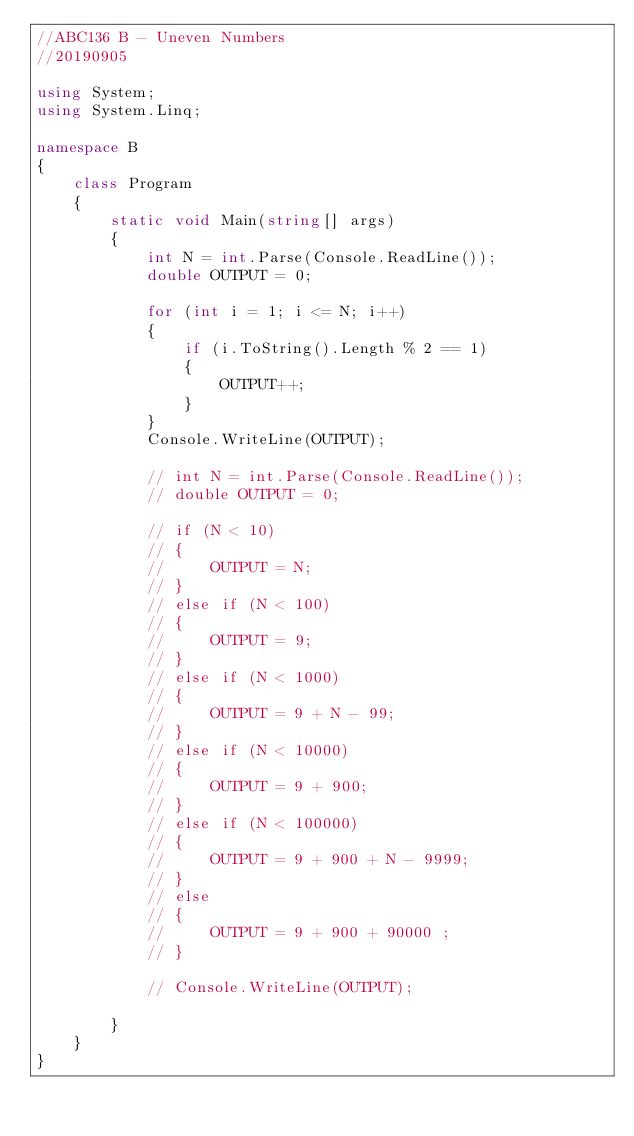Convert code to text. <code><loc_0><loc_0><loc_500><loc_500><_C#_>//ABC136 B - Uneven Numbers
//20190905

using System;
using System.Linq;

namespace B
{
    class Program
    {
        static void Main(string[] args)
        {
            int N = int.Parse(Console.ReadLine());
            double OUTPUT = 0;

            for (int i = 1; i <= N; i++)
            {
                if (i.ToString().Length % 2 == 1)
                {
                    OUTPUT++;
                }
            }
            Console.WriteLine(OUTPUT);

            // int N = int.Parse(Console.ReadLine());
            // double OUTPUT = 0;

            // if (N < 10)
            // {
            //     OUTPUT = N;
            // }
            // else if (N < 100)
            // {
            //     OUTPUT = 9;
            // }
            // else if (N < 1000)
            // {
            //     OUTPUT = 9 + N - 99;
            // }
            // else if (N < 10000)
            // {
            //     OUTPUT = 9 + 900;
            // }
            // else if (N < 100000)
            // {
            //     OUTPUT = 9 + 900 + N - 9999;
            // }
            // else
            // {
            //     OUTPUT = 9 + 900 + 90000 ;
            // }

            // Console.WriteLine(OUTPUT);

        }
    }
}
</code> 